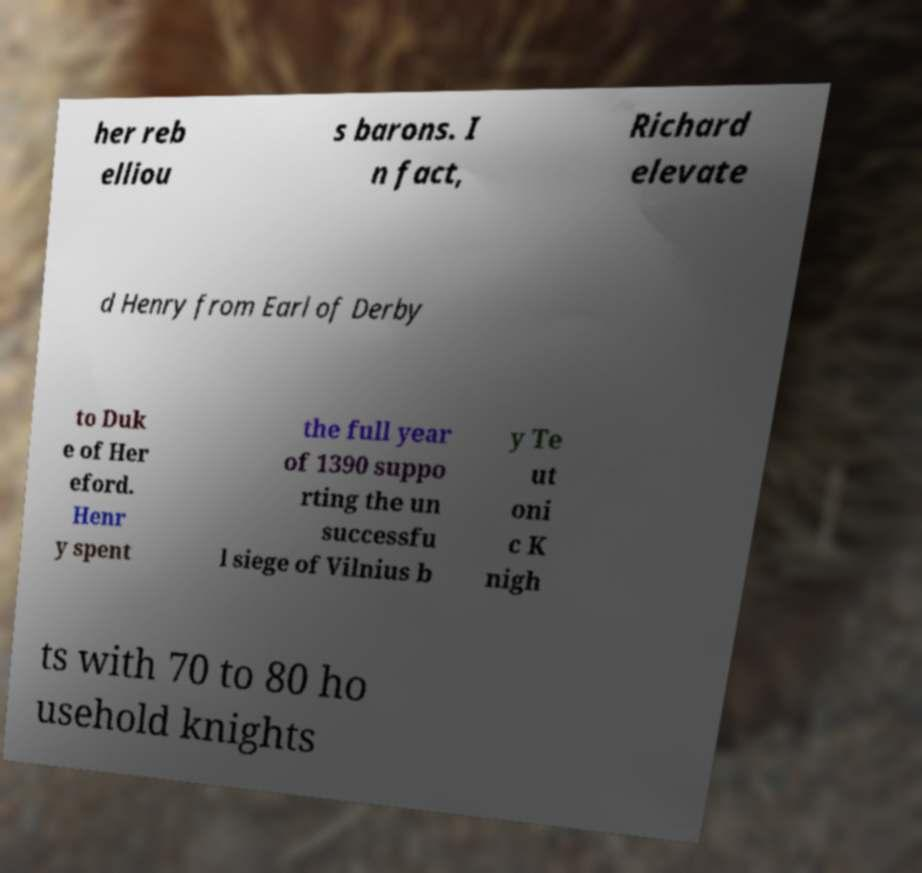I need the written content from this picture converted into text. Can you do that? her reb elliou s barons. I n fact, Richard elevate d Henry from Earl of Derby to Duk e of Her eford. Henr y spent the full year of 1390 suppo rting the un successfu l siege of Vilnius b y Te ut oni c K nigh ts with 70 to 80 ho usehold knights 